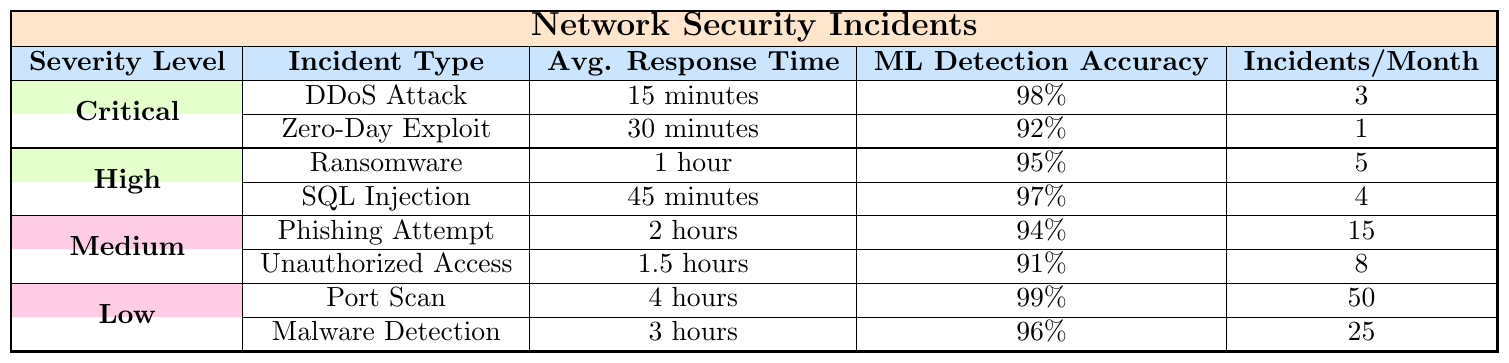What is the average response time for Critical incidents? From the table, the average response time for DDoS Attack is 15 minutes and for Zero-Day Exploit is 30 minutes. To find the average, we convert both times into minutes: (15 + 30) / 2 = 22.5 minutes
Answer: 22.5 minutes How many incidents per month are reported for High severity incidents? The table lists the incidents for High severity incidents as Ransomware (5 incidents) and SQL Injection (4 incidents). Adding these gives 5 + 4 = 9 incidents per month
Answer: 9 incidents Is the ML Detection Accuracy for Port Scan higher than that for Ransomware? The table shows that the ML Detection Accuracy for Port Scan is 99% and for Ransomware, it is 95%. Since 99% is greater than 95%, the statement is true
Answer: Yes What is the total number of incidents per month for Medium severity incidents? For Medium severity, there are Phishing Attempt (15 incidents) and Unauthorized Access (8 incidents). Summing these gives 15 + 8 = 23 incidents per month
Answer: 23 incidents Which incident type has the longest average response time in the Low severity category? In the Low severity category, the average response time for Port Scan is 4 hours and for Malware Detection it is 3 hours. Since 4 hours is greater than 3 hours, Port Scan has the longest response time
Answer: Port Scan What is the percentage difference in ML Detection Accuracy between Critical and Medium severity levels? For Critical incidents, the accuracy is calculated as [(98% + 92%) / 2] = 95%. For Medium incidents, the accuracy is [(94% + 91%) / 2] = 92.5%. The percentage difference is (95 - 92.5) / ((95 + 92.5) / 2) * 100 = 2.57%
Answer: 2.57% Are there more incidents in the Low severity category or the High severity category? For the Low severity category, there are 50 (Port Scan) + 25 (Malware Detection) = 75 incidents. For High severity, there are 5 (Ransomware) + 4 (SQL Injection) = 9 incidents. Since 75 is greater than 9, there are more incidents in Low severity
Answer: Low severity What is the overall average response time across all incident types? The average response times are: Critical (22.5 minutes), High (75 minutes), Medium (120 minutes), Low (195 minutes). Converting to a common unit of hours (22.5/60, 75/60, 120/60, 195/60) and averaging gives (0.375 + 1.25 + 2 + 3.25) / 4 = 1.25 hours
Answer: 1.25 hours How many more incidents does the Low severity category have compared to the Critical category? Low severity has 75 incidents, and Critical has 4 incidents (3 for DDoS and 1 for Zero-Day). The difference is 75 - 4 = 71 incidents
Answer: 71 incidents Which incident type in the High severity category has the highest ML Detection Accuracy? In the High severity category, Ransomware has 95% and SQL Injection has 97%. Since 97% is greater than 95%, SQL Injection has the highest ML Detection Accuracy
Answer: SQL Injection 